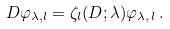<formula> <loc_0><loc_0><loc_500><loc_500>D \varphi _ { \lambda , l } = \zeta _ { l } ( D ; \lambda ) \varphi _ { \lambda , \, l } \, .</formula> 